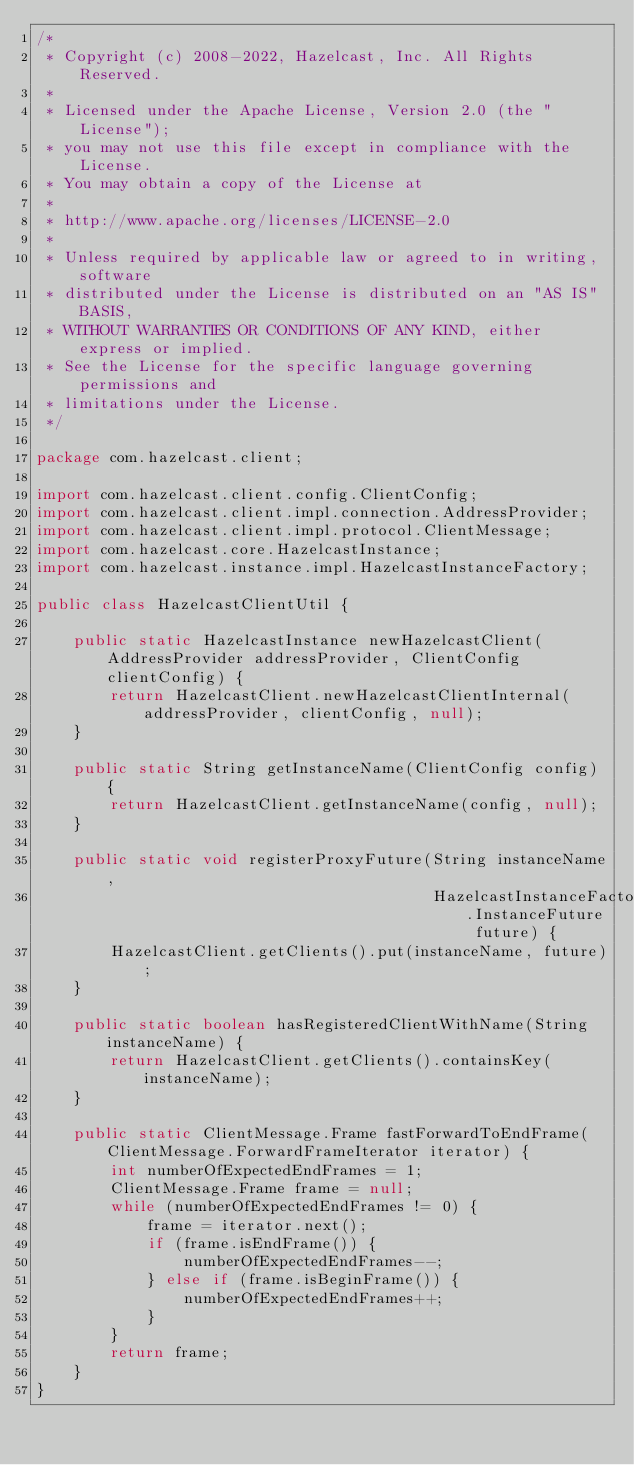<code> <loc_0><loc_0><loc_500><loc_500><_Java_>/*
 * Copyright (c) 2008-2022, Hazelcast, Inc. All Rights Reserved.
 *
 * Licensed under the Apache License, Version 2.0 (the "License");
 * you may not use this file except in compliance with the License.
 * You may obtain a copy of the License at
 *
 * http://www.apache.org/licenses/LICENSE-2.0
 *
 * Unless required by applicable law or agreed to in writing, software
 * distributed under the License is distributed on an "AS IS" BASIS,
 * WITHOUT WARRANTIES OR CONDITIONS OF ANY KIND, either express or implied.
 * See the License for the specific language governing permissions and
 * limitations under the License.
 */

package com.hazelcast.client;

import com.hazelcast.client.config.ClientConfig;
import com.hazelcast.client.impl.connection.AddressProvider;
import com.hazelcast.client.impl.protocol.ClientMessage;
import com.hazelcast.core.HazelcastInstance;
import com.hazelcast.instance.impl.HazelcastInstanceFactory;

public class HazelcastClientUtil {

    public static HazelcastInstance newHazelcastClient(AddressProvider addressProvider, ClientConfig clientConfig) {
        return HazelcastClient.newHazelcastClientInternal(addressProvider, clientConfig, null);
    }

    public static String getInstanceName(ClientConfig config) {
        return HazelcastClient.getInstanceName(config, null);
    }

    public static void registerProxyFuture(String instanceName,
                                           HazelcastInstanceFactory.InstanceFuture future) {
        HazelcastClient.getClients().put(instanceName, future);
    }

    public static boolean hasRegisteredClientWithName(String instanceName) {
        return HazelcastClient.getClients().containsKey(instanceName);
    }

    public static ClientMessage.Frame fastForwardToEndFrame(ClientMessage.ForwardFrameIterator iterator) {
        int numberOfExpectedEndFrames = 1;
        ClientMessage.Frame frame = null;
        while (numberOfExpectedEndFrames != 0) {
            frame = iterator.next();
            if (frame.isEndFrame()) {
                numberOfExpectedEndFrames--;
            } else if (frame.isBeginFrame()) {
                numberOfExpectedEndFrames++;
            }
        }
        return frame;
    }
}
</code> 